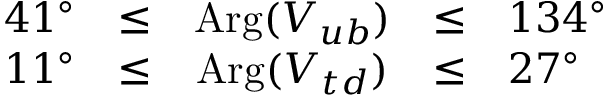<formula> <loc_0><loc_0><loc_500><loc_500>\begin{array} { r c c c l } { { 4 1 ^ { \circ } } } & { \leq } & { { A r g ( V _ { u b } ) } } & { \leq } & { { 1 3 4 ^ { \circ } } } \\ { { 1 1 ^ { \circ } } } & { \leq } & { { A r g ( V _ { t d } ) } } & { \leq } & { { 2 7 ^ { \circ } } } \end{array}</formula> 